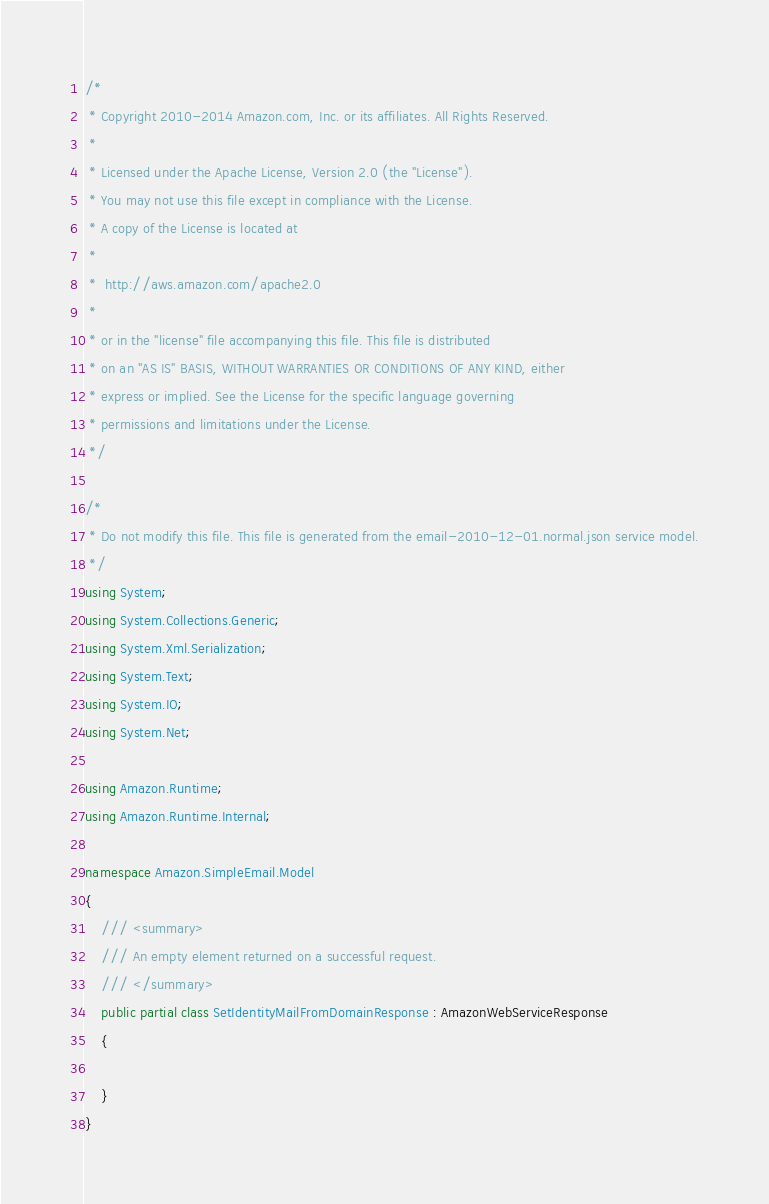<code> <loc_0><loc_0><loc_500><loc_500><_C#_>/*
 * Copyright 2010-2014 Amazon.com, Inc. or its affiliates. All Rights Reserved.
 * 
 * Licensed under the Apache License, Version 2.0 (the "License").
 * You may not use this file except in compliance with the License.
 * A copy of the License is located at
 * 
 *  http://aws.amazon.com/apache2.0
 * 
 * or in the "license" file accompanying this file. This file is distributed
 * on an "AS IS" BASIS, WITHOUT WARRANTIES OR CONDITIONS OF ANY KIND, either
 * express or implied. See the License for the specific language governing
 * permissions and limitations under the License.
 */

/*
 * Do not modify this file. This file is generated from the email-2010-12-01.normal.json service model.
 */
using System;
using System.Collections.Generic;
using System.Xml.Serialization;
using System.Text;
using System.IO;
using System.Net;

using Amazon.Runtime;
using Amazon.Runtime.Internal;

namespace Amazon.SimpleEmail.Model
{
    /// <summary>
    /// An empty element returned on a successful request.
    /// </summary>
    public partial class SetIdentityMailFromDomainResponse : AmazonWebServiceResponse
    {

    }
}</code> 